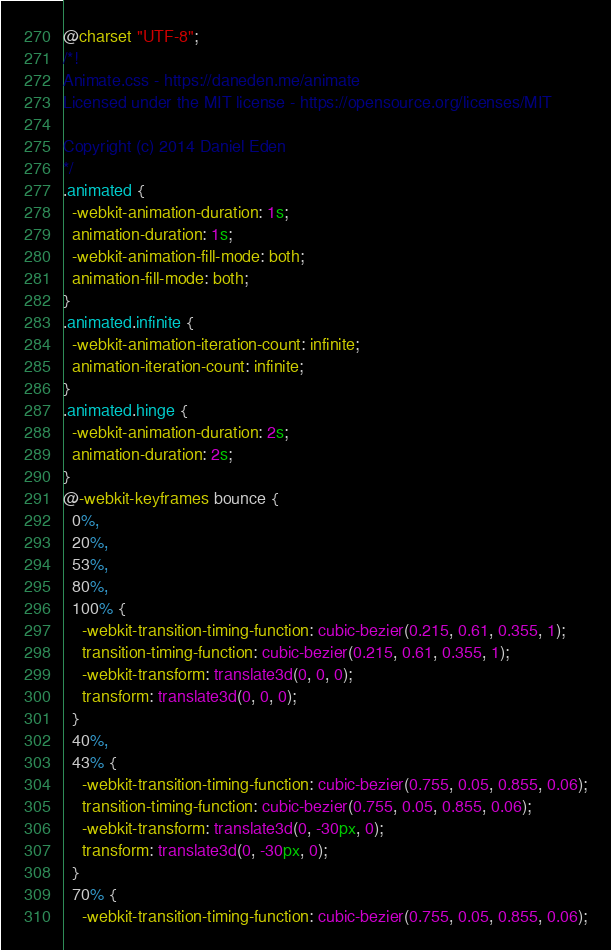<code> <loc_0><loc_0><loc_500><loc_500><_CSS_>@charset "UTF-8";
/*!
Animate.css - https://daneden.me/animate
Licensed under the MIT license - https://opensource.org/licenses/MIT

Copyright (c) 2014 Daniel Eden
*/
.animated {
  -webkit-animation-duration: 1s;
  animation-duration: 1s;
  -webkit-animation-fill-mode: both;
  animation-fill-mode: both;
}
.animated.infinite {
  -webkit-animation-iteration-count: infinite;
  animation-iteration-count: infinite;
}
.animated.hinge {
  -webkit-animation-duration: 2s;
  animation-duration: 2s;
}
@-webkit-keyframes bounce {
  0%,
  20%,
  53%,
  80%,
  100% {
    -webkit-transition-timing-function: cubic-bezier(0.215, 0.61, 0.355, 1);
    transition-timing-function: cubic-bezier(0.215, 0.61, 0.355, 1);
    -webkit-transform: translate3d(0, 0, 0);
    transform: translate3d(0, 0, 0);
  }
  40%,
  43% {
    -webkit-transition-timing-function: cubic-bezier(0.755, 0.05, 0.855, 0.06);
    transition-timing-function: cubic-bezier(0.755, 0.05, 0.855, 0.06);
    -webkit-transform: translate3d(0, -30px, 0);
    transform: translate3d(0, -30px, 0);
  }
  70% {
    -webkit-transition-timing-function: cubic-bezier(0.755, 0.05, 0.855, 0.06);</code> 